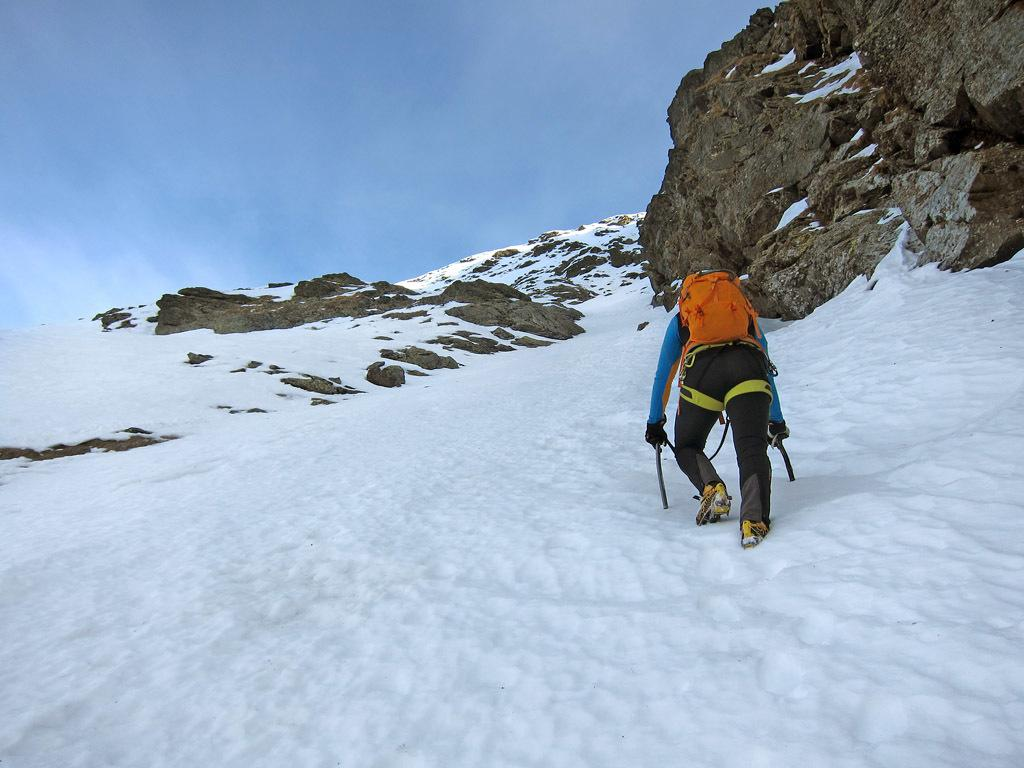What is the person in the image doing? The person is climbing in the image. Where is the person climbing? The person is climbing on a hill. What can be seen at the top of the hill? The sky is visible at the top of the hill. What type of terrain is the person climbing on? There are rocks on the hill. What color is the pig that is waving at the person climbing in the image? There is no pig present in the image, and no one is waving at the person climbing. 